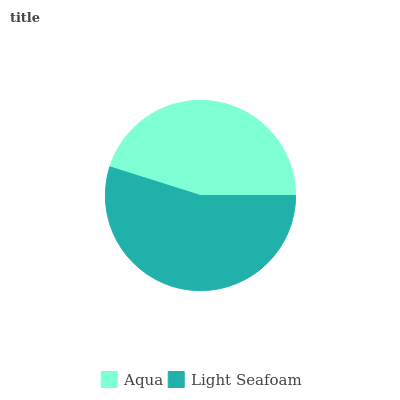Is Aqua the minimum?
Answer yes or no. Yes. Is Light Seafoam the maximum?
Answer yes or no. Yes. Is Light Seafoam the minimum?
Answer yes or no. No. Is Light Seafoam greater than Aqua?
Answer yes or no. Yes. Is Aqua less than Light Seafoam?
Answer yes or no. Yes. Is Aqua greater than Light Seafoam?
Answer yes or no. No. Is Light Seafoam less than Aqua?
Answer yes or no. No. Is Light Seafoam the high median?
Answer yes or no. Yes. Is Aqua the low median?
Answer yes or no. Yes. Is Aqua the high median?
Answer yes or no. No. Is Light Seafoam the low median?
Answer yes or no. No. 